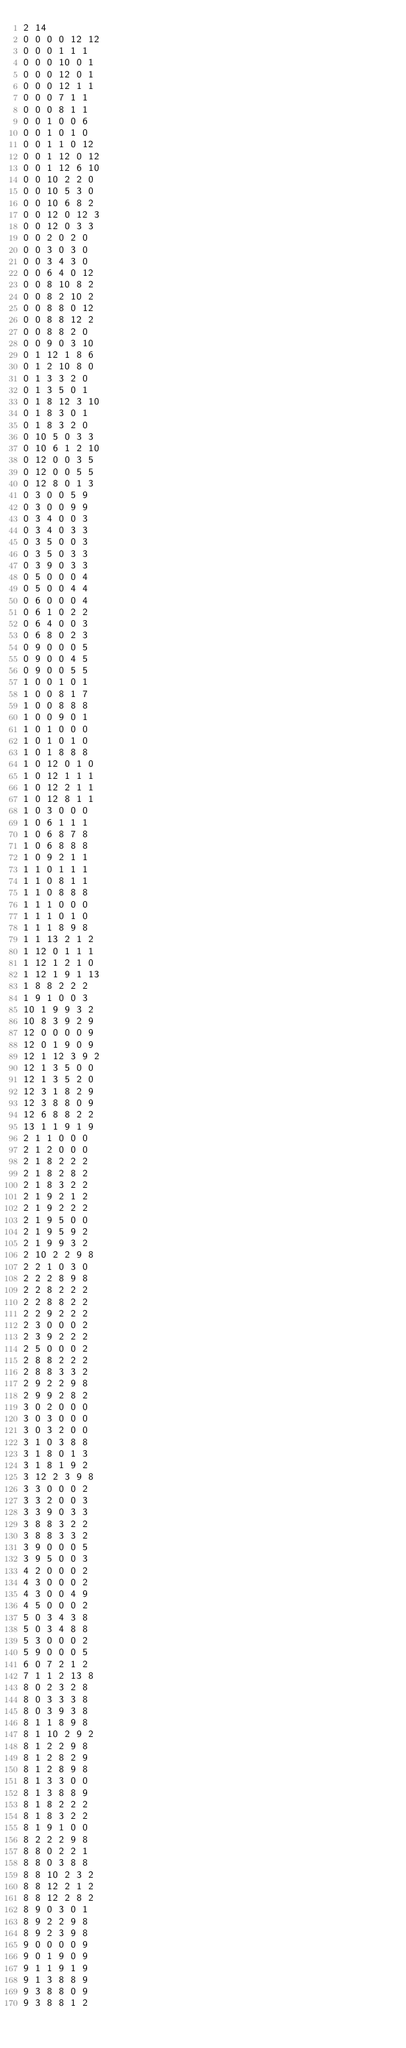<code> <loc_0><loc_0><loc_500><loc_500><_SQL_>2 14
0 0 0 0 12 12
0 0 0 1 1 1
0 0 0 10 0 1
0 0 0 12 0 1
0 0 0 12 1 1
0 0 0 7 1 1
0 0 0 8 1 1
0 0 1 0 0 6
0 0 1 0 1 0
0 0 1 1 0 12
0 0 1 12 0 12
0 0 1 12 6 10
0 0 10 2 2 0
0 0 10 5 3 0
0 0 10 6 8 2
0 0 12 0 12 3
0 0 12 0 3 3
0 0 2 0 2 0
0 0 3 0 3 0
0 0 3 4 3 0
0 0 6 4 0 12
0 0 8 10 8 2
0 0 8 2 10 2
0 0 8 8 0 12
0 0 8 8 12 2
0 0 8 8 2 0
0 0 9 0 3 10
0 1 12 1 8 6
0 1 2 10 8 0
0 1 3 3 2 0
0 1 3 5 0 1
0 1 8 12 3 10
0 1 8 3 0 1
0 1 8 3 2 0
0 10 5 0 3 3
0 10 6 1 2 10
0 12 0 0 3 5
0 12 0 0 5 5
0 12 8 0 1 3
0 3 0 0 5 9
0 3 0 0 9 9
0 3 4 0 0 3
0 3 4 0 3 3
0 3 5 0 0 3
0 3 5 0 3 3
0 3 9 0 3 3
0 5 0 0 0 4
0 5 0 0 4 4
0 6 0 0 0 4
0 6 1 0 2 2
0 6 4 0 0 3
0 6 8 0 2 3
0 9 0 0 0 5
0 9 0 0 4 5
0 9 0 0 5 5
1 0 0 1 0 1
1 0 0 8 1 7
1 0 0 8 8 8
1 0 0 9 0 1
1 0 1 0 0 0
1 0 1 0 1 0
1 0 1 8 8 8
1 0 12 0 1 0
1 0 12 1 1 1
1 0 12 2 1 1
1 0 12 8 1 1
1 0 3 0 0 0
1 0 6 1 1 1
1 0 6 8 7 8
1 0 6 8 8 8
1 0 9 2 1 1
1 1 0 1 1 1
1 1 0 8 1 1
1 1 0 8 8 8
1 1 1 0 0 0
1 1 1 0 1 0
1 1 1 8 9 8
1 1 13 2 1 2
1 12 0 1 1 1
1 12 1 2 1 0
1 12 1 9 1 13
1 8 8 2 2 2
1 9 1 0 0 3
10 1 9 9 3 2
10 8 3 9 2 9
12 0 0 0 0 9
12 0 1 9 0 9
12 1 12 3 9 2
12 1 3 5 0 0
12 1 3 5 2 0
12 3 1 8 2 9
12 3 8 8 0 9
12 6 8 8 2 2
13 1 1 9 1 9
2 1 1 0 0 0
2 1 2 0 0 0
2 1 8 2 2 2
2 1 8 2 8 2
2 1 8 3 2 2
2 1 9 2 1 2
2 1 9 2 2 2
2 1 9 5 0 0
2 1 9 5 9 2
2 1 9 9 3 2
2 10 2 2 9 8
2 2 1 0 3 0
2 2 2 8 9 8
2 2 8 2 2 2
2 2 8 8 2 2
2 2 9 2 2 2
2 3 0 0 0 2
2 3 9 2 2 2
2 5 0 0 0 2
2 8 8 2 2 2
2 8 8 3 3 2
2 9 2 2 9 8
2 9 9 2 8 2
3 0 2 0 0 0
3 0 3 0 0 0
3 0 3 2 0 0
3 1 0 3 8 8
3 1 8 0 1 3
3 1 8 1 9 2
3 12 2 3 9 8
3 3 0 0 0 2
3 3 2 0 0 3
3 3 9 0 3 3
3 8 8 3 2 2
3 8 8 3 3 2
3 9 0 0 0 5
3 9 5 0 0 3
4 2 0 0 0 2
4 3 0 0 0 2
4 3 0 0 4 9
4 5 0 0 0 2
5 0 3 4 3 8
5 0 3 4 8 8
5 3 0 0 0 2
5 9 0 0 0 5
6 0 7 2 1 2
7 1 1 2 13 8
8 0 2 3 2 8
8 0 3 3 3 8
8 0 3 9 3 8
8 1 1 8 9 8
8 1 10 2 9 2
8 1 2 2 9 8
8 1 2 8 2 9
8 1 2 8 9 8
8 1 3 3 0 0
8 1 3 8 8 9
8 1 8 2 2 2
8 1 8 3 2 2
8 1 9 1 0 0
8 2 2 2 9 8
8 8 0 2 2 1
8 8 0 3 8 8
8 8 10 2 3 2
8 8 12 2 1 2
8 8 12 2 8 2
8 9 0 3 0 1
8 9 2 2 9 8
8 9 2 3 9 8
9 0 0 0 0 9
9 0 1 9 0 9
9 1 1 9 1 9
9 1 3 8 8 9
9 3 8 8 0 9
9 3 8 8 1 2
</code> 